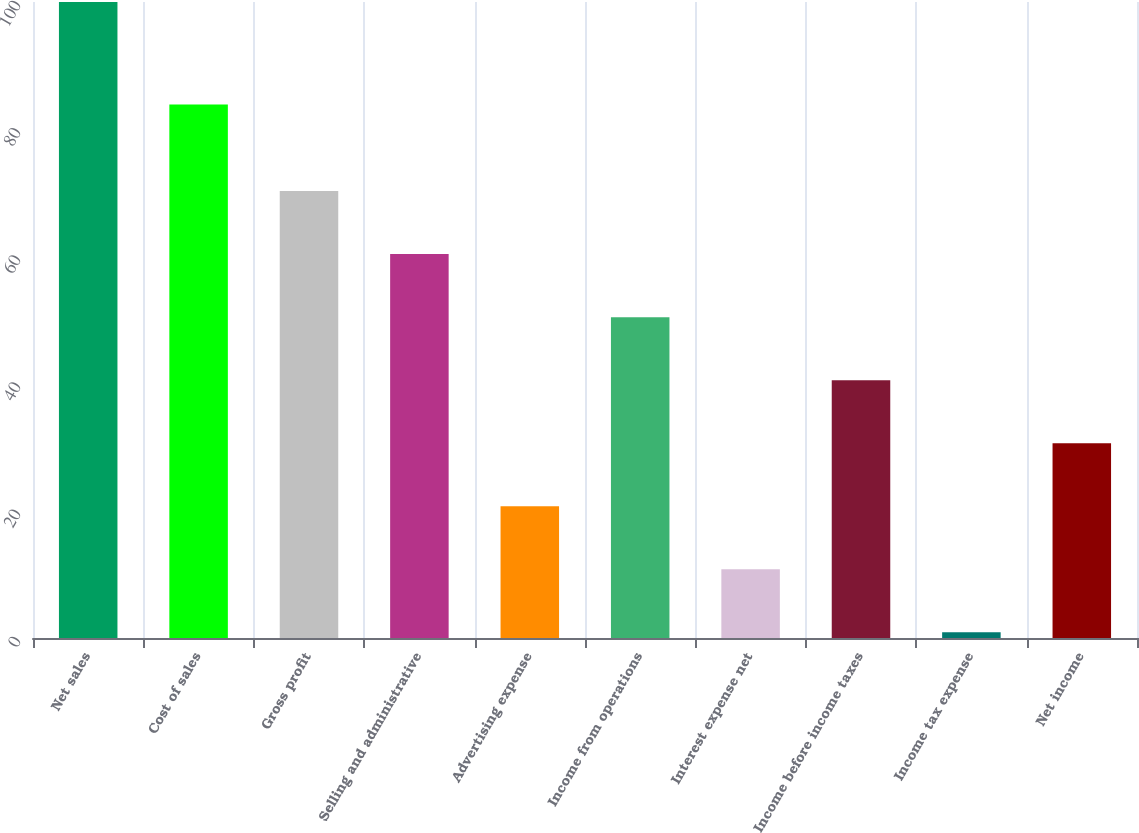Convert chart to OTSL. <chart><loc_0><loc_0><loc_500><loc_500><bar_chart><fcel>Net sales<fcel>Cost of sales<fcel>Gross profit<fcel>Selling and administrative<fcel>Advertising expense<fcel>Income from operations<fcel>Interest expense net<fcel>Income before income taxes<fcel>Income tax expense<fcel>Net income<nl><fcel>100<fcel>83.9<fcel>70.27<fcel>60.36<fcel>20.72<fcel>50.45<fcel>10.81<fcel>40.54<fcel>0.9<fcel>30.63<nl></chart> 